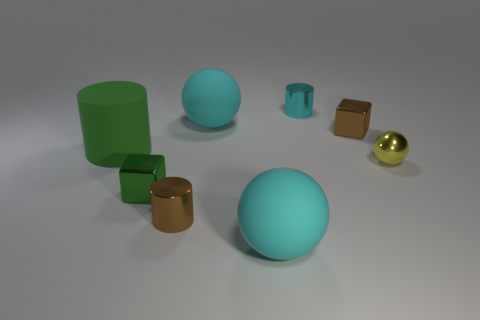If you had to associate a theme or message with this image, what would it be? The image might represent themes of simplicity and order, with each object carefully positioned and sized, evoking a sense of balance and deliberate design. 